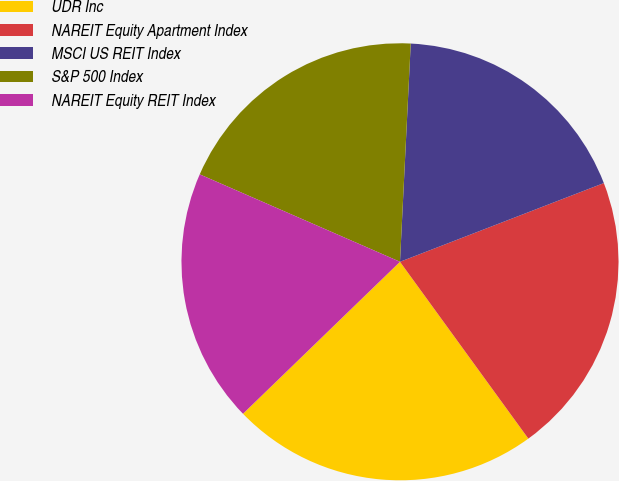Convert chart. <chart><loc_0><loc_0><loc_500><loc_500><pie_chart><fcel>UDR Inc<fcel>NAREIT Equity Apartment Index<fcel>MSCI US REIT Index<fcel>S&P 500 Index<fcel>NAREIT Equity REIT Index<nl><fcel>22.75%<fcel>20.87%<fcel>18.35%<fcel>19.23%<fcel>18.79%<nl></chart> 